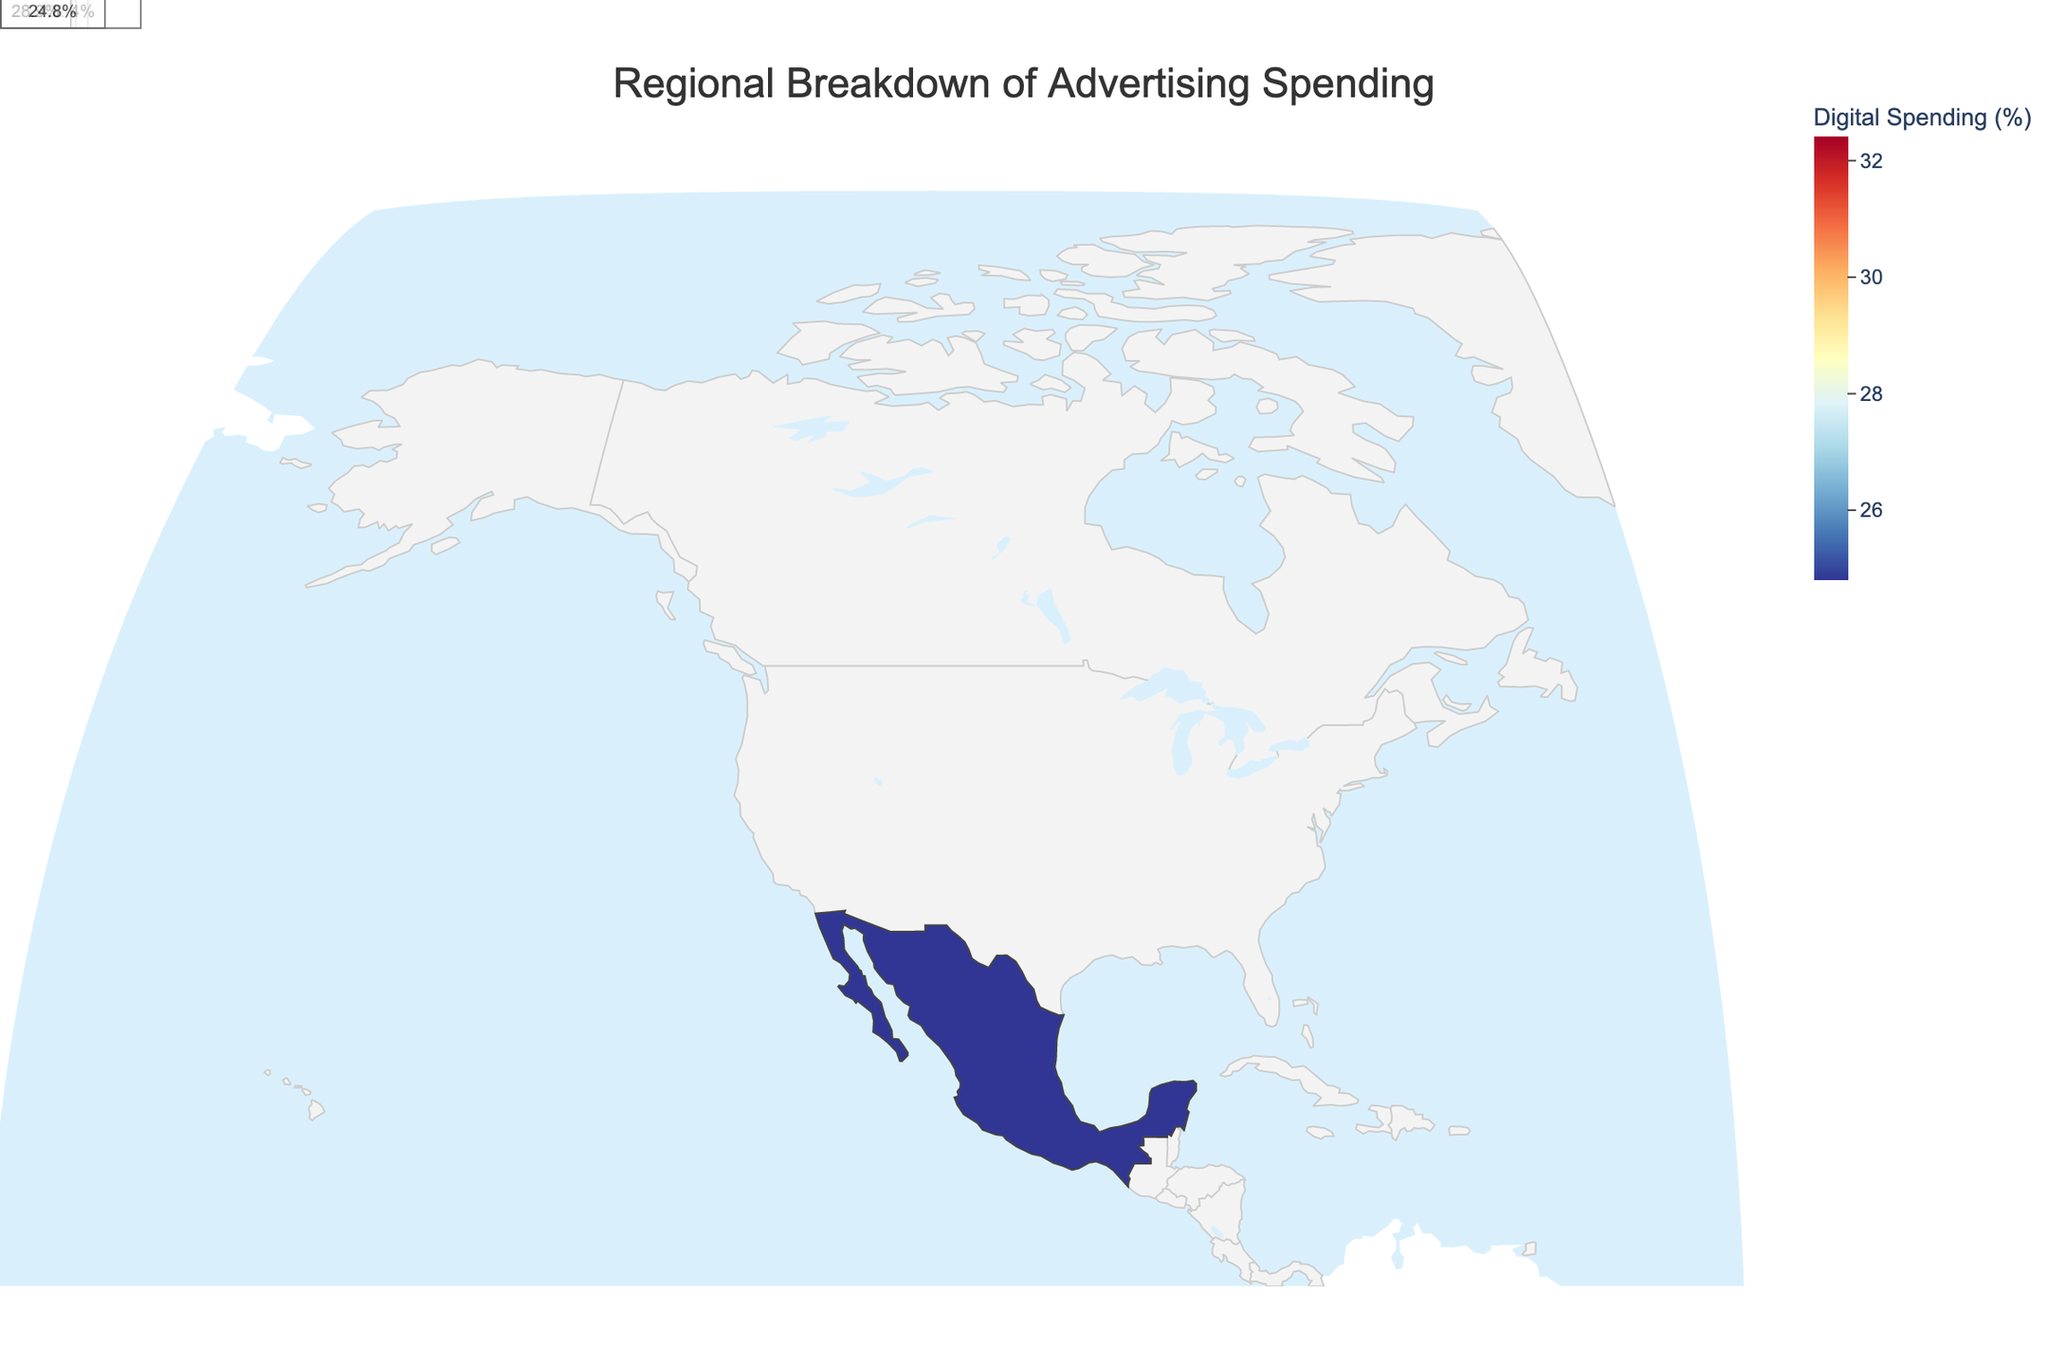What's the title of the figure? The title is usually located at the top of the plot. In this case, the title is clearly stated as 'Regional Breakdown of Advertising Spending'.
Answer: Regional Breakdown of Advertising Spending Which region has the highest digital spending percentage? Examine the color intensity and check the digital spending percentages. The highest value is indicated for British Columbia with 32.4%.
Answer: British Columbia How much higher is digital spending in California compared to Quebec? Look at the percentages for both regions: California is 31.5% and Quebec is 25.6%. Subtract Quebec's value from California's. 31.5 - 25.6 = 5.9.
Answer: 5.9% What are the five media channels displayed in the plot's hover data? Examine the hover data provided in the plot for the regions. They include TV, Digital, Print, Radio, and Outdoor.
Answer: TV, Digital, Print, Radio, Outdoor Which region has the lowest spending in TV? By comparing the TV spending values across regions, Quebec has the lowest value with 27.8%.
Answer: Quebec What is the total percentage of spending in digital and radio for Ontario? Check Ontario's values for digital and radio: 30.2% (Digital) and 9.8% (Radio). Sum them: 30.2 + 9.8 = 40.
Answer: 40% Compare the print spending in Florida and Illinois. Which one is higher? Florida has 11.8% in print while Illinois has 13.7%. By comparing the two, Illinois has higher print spending.
Answer: Illinois Which regions have a higher outdoor spending than TV spending? Check each region's outdoor and TV values: Texas, Quebec, Ontario, British Columbia, Alberta, and Mexico City have higher outdoor spending percentages than TV.
Answer: Texas, Quebec, Ontario, British Columbia, Alberta, Mexico City What is the average digital spending percentage across all regions? Sum the digital spending percentages: 28.7 + 31.5 + 26.3 + 29.8 + 27.9 + 30.2 + 25.6 + 32.4 + 28.9 + 24.8 = 286.1. Divide by the number of regions (10): 286.1 / 10 = 28.61.
Answer: 28.61% Which region shows the closest percentage for digital and TV spending? Compare the differences between digital and TV for each region: New York's values are closest with 35.2 (TV) and 28.7 (Digital), a difference of 6.5.
Answer: New York 